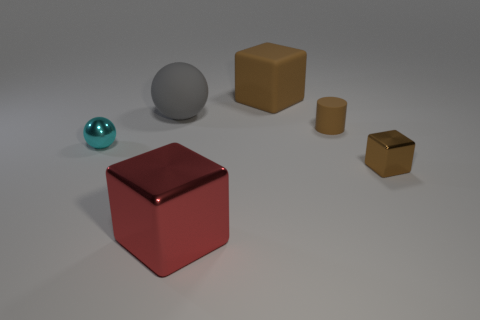There is a big brown thing that is the same shape as the red thing; what is its material?
Make the answer very short. Rubber. Are the brown cube that is in front of the cyan metallic thing and the large cube in front of the big brown block made of the same material?
Provide a succinct answer. Yes. What size is the rubber object that is both behind the tiny cylinder and right of the gray thing?
Your answer should be very brief. Large. There is another brown object that is the same size as the brown metal thing; what material is it?
Provide a short and direct response. Rubber. There is a block in front of the brown object in front of the cylinder; how many red metal blocks are behind it?
Keep it short and to the point. 0. There is a tiny thing that is left of the big metal thing; is it the same color as the tiny metallic object to the right of the cylinder?
Provide a short and direct response. No. What is the color of the tiny object that is right of the rubber ball and behind the tiny block?
Give a very brief answer. Brown. How many other rubber balls are the same size as the gray matte sphere?
Offer a terse response. 0. What is the shape of the small brown object behind the tiny metallic thing that is on the left side of the red cube?
Make the answer very short. Cylinder. What is the shape of the tiny metal thing that is in front of the small metallic object left of the brown thing that is to the left of the small brown cylinder?
Offer a terse response. Cube. 